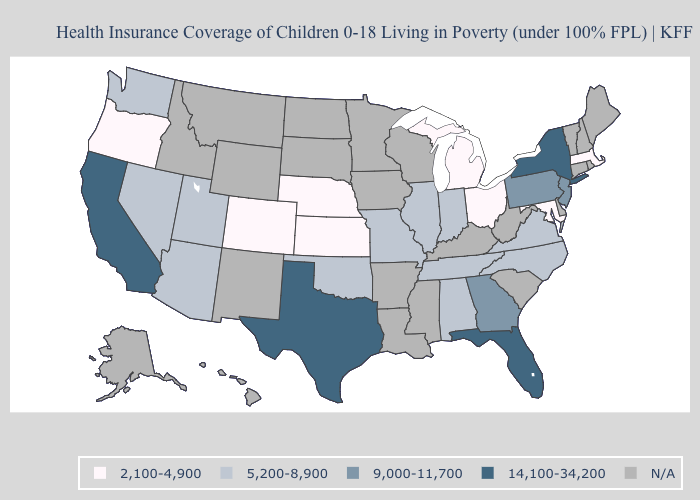What is the lowest value in the MidWest?
Write a very short answer. 2,100-4,900. Among the states that border Kentucky , does Ohio have the highest value?
Concise answer only. No. Does New York have the highest value in the USA?
Quick response, please. Yes. Name the states that have a value in the range 9,000-11,700?
Give a very brief answer. Georgia, New Jersey, Pennsylvania. What is the lowest value in the South?
Give a very brief answer. 2,100-4,900. Name the states that have a value in the range 2,100-4,900?
Concise answer only. Colorado, Kansas, Maryland, Massachusetts, Michigan, Nebraska, Ohio, Oregon. Among the states that border West Virginia , which have the lowest value?
Answer briefly. Maryland, Ohio. Does Florida have the highest value in the South?
Short answer required. Yes. Which states have the highest value in the USA?
Concise answer only. California, Florida, New York, Texas. Name the states that have a value in the range 2,100-4,900?
Be succinct. Colorado, Kansas, Maryland, Massachusetts, Michigan, Nebraska, Ohio, Oregon. Does the map have missing data?
Keep it brief. Yes. Which states have the lowest value in the USA?
Write a very short answer. Colorado, Kansas, Maryland, Massachusetts, Michigan, Nebraska, Ohio, Oregon. How many symbols are there in the legend?
Be succinct. 5. Name the states that have a value in the range 9,000-11,700?
Write a very short answer. Georgia, New Jersey, Pennsylvania. 